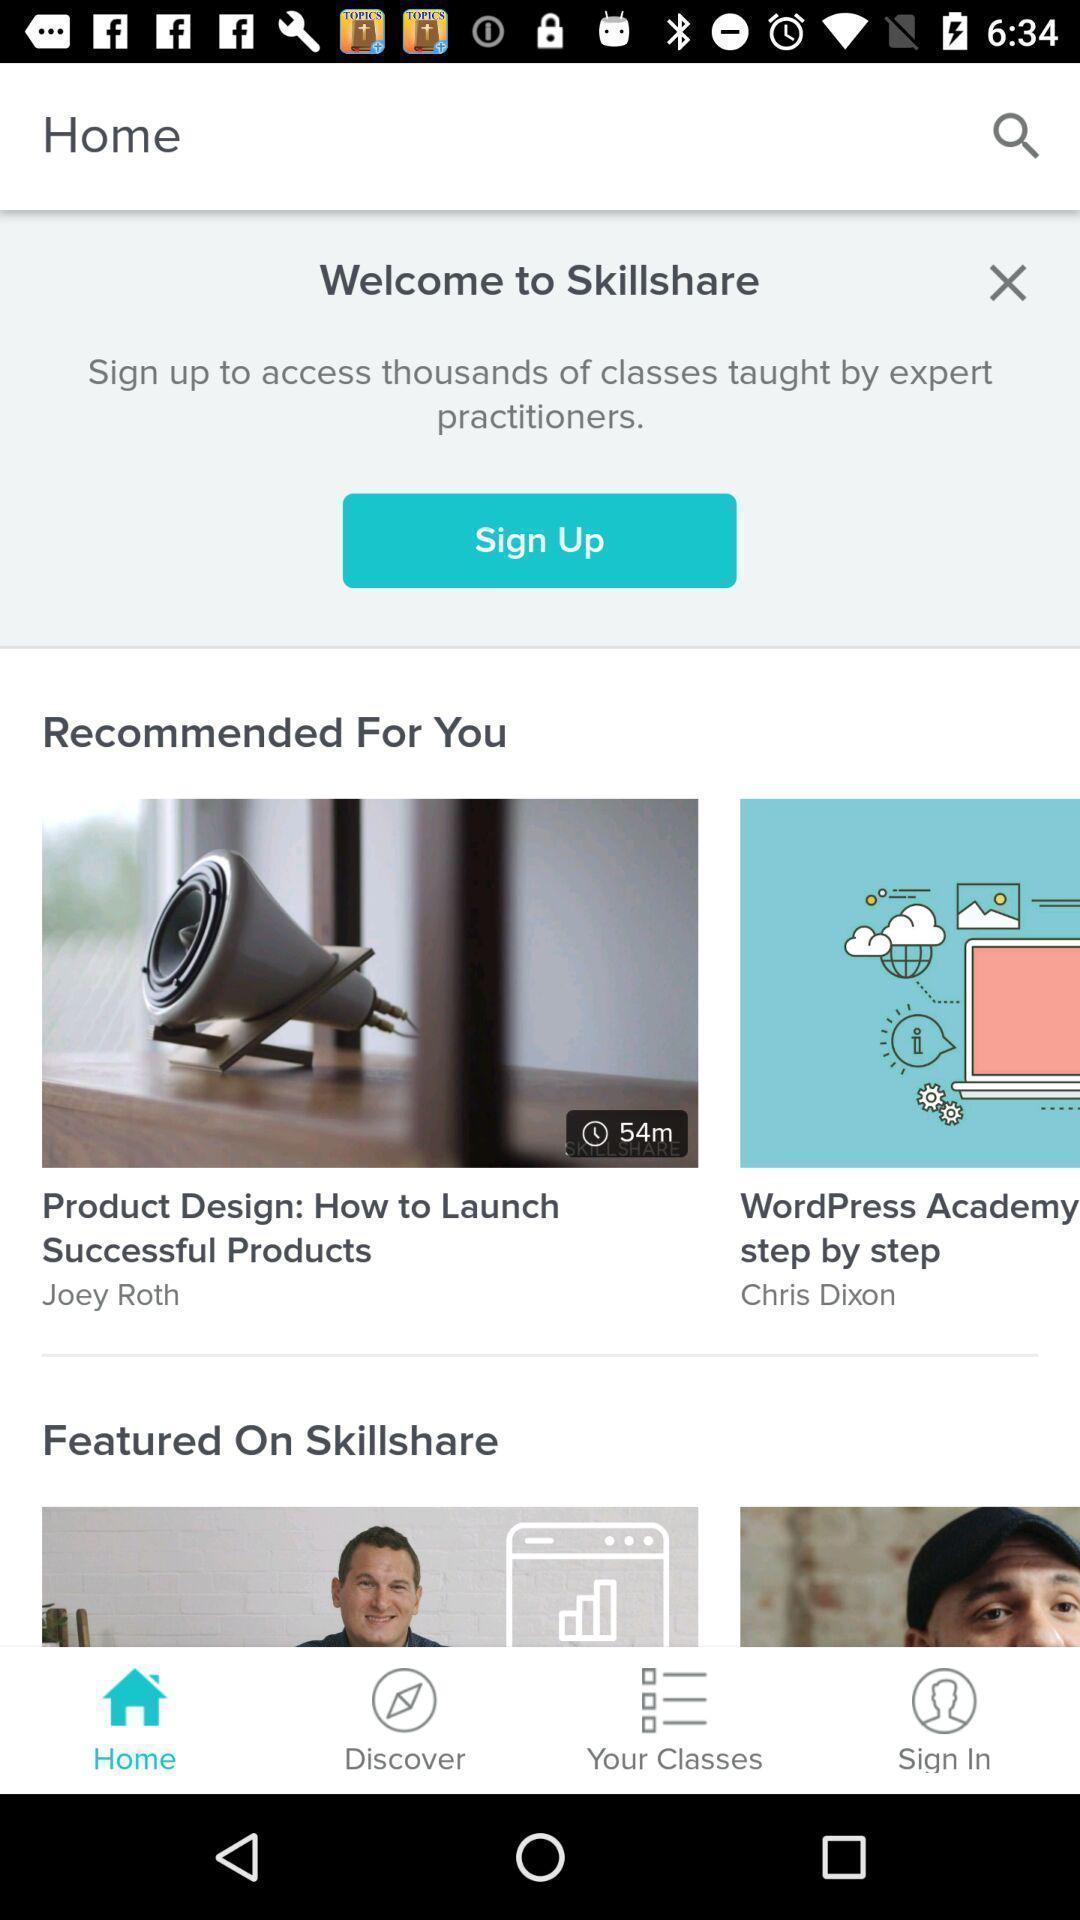Explain what's happening in this screen capture. Welcome page. 